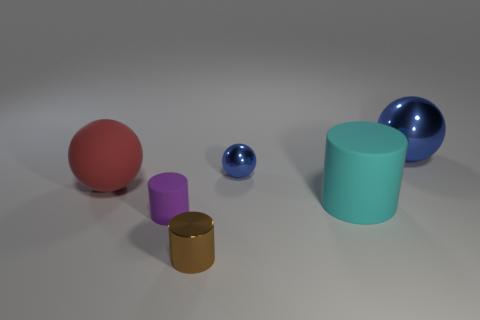Subtract all rubber cylinders. How many cylinders are left? 1 Add 3 brown shiny cylinders. How many objects exist? 9 Subtract 1 cylinders. How many cylinders are left? 2 Subtract all purple cylinders. How many cylinders are left? 2 Add 3 brown cylinders. How many brown cylinders are left? 4 Add 5 blue rubber cubes. How many blue rubber cubes exist? 5 Subtract 0 yellow spheres. How many objects are left? 6 Subtract all brown balls. Subtract all green cylinders. How many balls are left? 3 Subtract all purple blocks. How many blue cylinders are left? 0 Subtract all tiny balls. Subtract all cyan matte things. How many objects are left? 4 